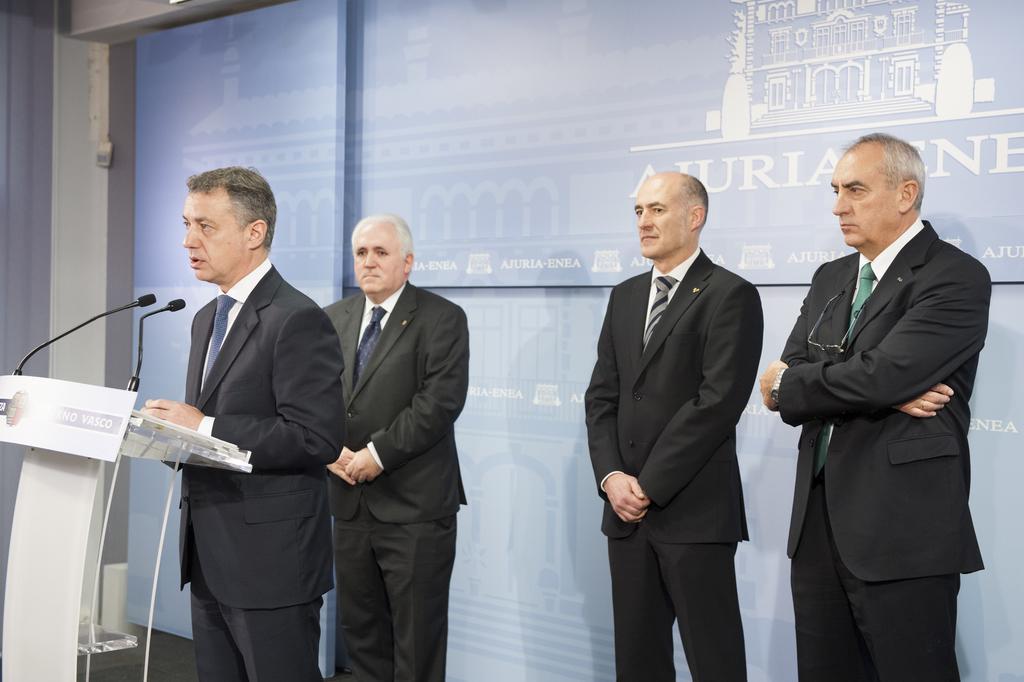In one or two sentences, can you explain what this image depicts? This image is taken indoors. In the background there is a banner with an image and a text on it and there is a wall. On the right side of the image two men are standing on the dais. On the left side of the image there is a podium with two mics and two men are standing on the dais. They have worn suits, shirts and ties. 